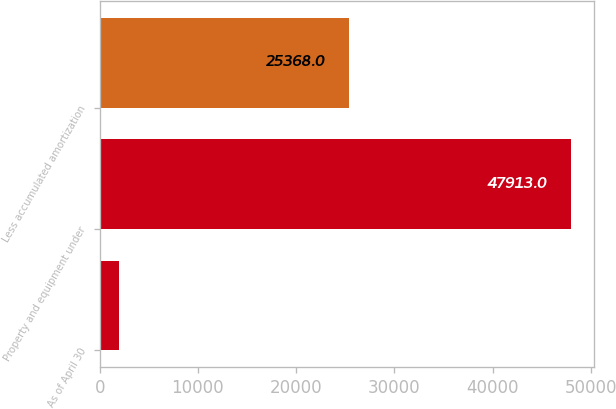<chart> <loc_0><loc_0><loc_500><loc_500><bar_chart><fcel>As of April 30<fcel>Property and equipment under<fcel>Less accumulated amortization<nl><fcel>2009<fcel>47913<fcel>25368<nl></chart> 